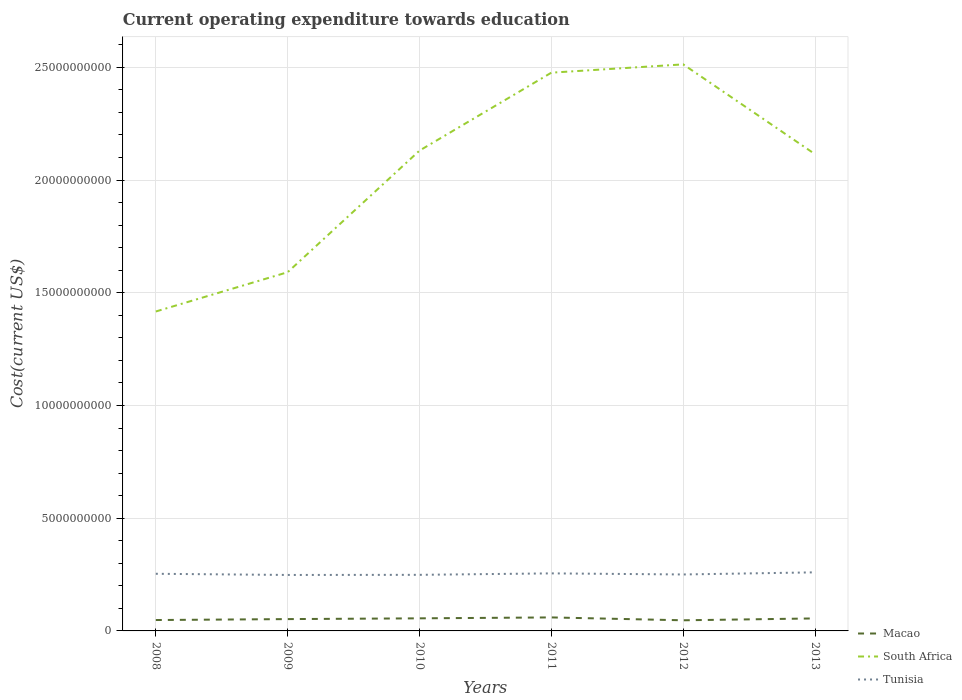How many different coloured lines are there?
Offer a terse response. 3. Does the line corresponding to Macao intersect with the line corresponding to Tunisia?
Make the answer very short. No. Is the number of lines equal to the number of legend labels?
Offer a terse response. Yes. Across all years, what is the maximum expenditure towards education in Tunisia?
Provide a short and direct response. 2.48e+09. What is the total expenditure towards education in Macao in the graph?
Provide a succinct answer. 4.42e+07. What is the difference between the highest and the second highest expenditure towards education in Macao?
Provide a short and direct response. 1.28e+08. Is the expenditure towards education in Tunisia strictly greater than the expenditure towards education in South Africa over the years?
Your response must be concise. Yes. What is the difference between two consecutive major ticks on the Y-axis?
Your answer should be very brief. 5.00e+09. Does the graph contain any zero values?
Ensure brevity in your answer.  No. Does the graph contain grids?
Keep it short and to the point. Yes. How many legend labels are there?
Ensure brevity in your answer.  3. How are the legend labels stacked?
Provide a succinct answer. Vertical. What is the title of the graph?
Your answer should be compact. Current operating expenditure towards education. Does "India" appear as one of the legend labels in the graph?
Your response must be concise. No. What is the label or title of the Y-axis?
Provide a succinct answer. Cost(current US$). What is the Cost(current US$) of Macao in 2008?
Your answer should be very brief. 4.83e+08. What is the Cost(current US$) in South Africa in 2008?
Your response must be concise. 1.42e+1. What is the Cost(current US$) in Tunisia in 2008?
Offer a very short reply. 2.53e+09. What is the Cost(current US$) in Macao in 2009?
Give a very brief answer. 5.25e+08. What is the Cost(current US$) of South Africa in 2009?
Keep it short and to the point. 1.59e+1. What is the Cost(current US$) in Tunisia in 2009?
Ensure brevity in your answer.  2.48e+09. What is the Cost(current US$) of Macao in 2010?
Ensure brevity in your answer.  5.58e+08. What is the Cost(current US$) of South Africa in 2010?
Give a very brief answer. 2.13e+1. What is the Cost(current US$) in Tunisia in 2010?
Offer a terse response. 2.49e+09. What is the Cost(current US$) of Macao in 2011?
Offer a very short reply. 5.99e+08. What is the Cost(current US$) in South Africa in 2011?
Ensure brevity in your answer.  2.48e+1. What is the Cost(current US$) of Tunisia in 2011?
Your response must be concise. 2.55e+09. What is the Cost(current US$) of Macao in 2012?
Provide a succinct answer. 4.71e+08. What is the Cost(current US$) in South Africa in 2012?
Provide a short and direct response. 2.51e+1. What is the Cost(current US$) of Tunisia in 2012?
Your response must be concise. 2.50e+09. What is the Cost(current US$) in Macao in 2013?
Provide a succinct answer. 5.55e+08. What is the Cost(current US$) in South Africa in 2013?
Offer a terse response. 2.11e+1. What is the Cost(current US$) of Tunisia in 2013?
Keep it short and to the point. 2.60e+09. Across all years, what is the maximum Cost(current US$) of Macao?
Give a very brief answer. 5.99e+08. Across all years, what is the maximum Cost(current US$) of South Africa?
Your answer should be very brief. 2.51e+1. Across all years, what is the maximum Cost(current US$) of Tunisia?
Offer a very short reply. 2.60e+09. Across all years, what is the minimum Cost(current US$) in Macao?
Your response must be concise. 4.71e+08. Across all years, what is the minimum Cost(current US$) of South Africa?
Keep it short and to the point. 1.42e+1. Across all years, what is the minimum Cost(current US$) in Tunisia?
Offer a terse response. 2.48e+09. What is the total Cost(current US$) in Macao in the graph?
Keep it short and to the point. 3.19e+09. What is the total Cost(current US$) in South Africa in the graph?
Keep it short and to the point. 1.22e+11. What is the total Cost(current US$) of Tunisia in the graph?
Keep it short and to the point. 1.52e+1. What is the difference between the Cost(current US$) in Macao in 2008 and that in 2009?
Ensure brevity in your answer.  -4.17e+07. What is the difference between the Cost(current US$) of South Africa in 2008 and that in 2009?
Your response must be concise. -1.74e+09. What is the difference between the Cost(current US$) of Tunisia in 2008 and that in 2009?
Provide a short and direct response. 5.23e+07. What is the difference between the Cost(current US$) in Macao in 2008 and that in 2010?
Your answer should be very brief. -7.51e+07. What is the difference between the Cost(current US$) of South Africa in 2008 and that in 2010?
Provide a succinct answer. -7.14e+09. What is the difference between the Cost(current US$) of Tunisia in 2008 and that in 2010?
Offer a terse response. 4.66e+07. What is the difference between the Cost(current US$) of Macao in 2008 and that in 2011?
Your answer should be compact. -1.16e+08. What is the difference between the Cost(current US$) in South Africa in 2008 and that in 2011?
Make the answer very short. -1.06e+1. What is the difference between the Cost(current US$) of Tunisia in 2008 and that in 2011?
Offer a very short reply. -1.80e+07. What is the difference between the Cost(current US$) of Macao in 2008 and that in 2012?
Your response must be concise. 1.18e+07. What is the difference between the Cost(current US$) in South Africa in 2008 and that in 2012?
Offer a very short reply. -1.10e+1. What is the difference between the Cost(current US$) of Tunisia in 2008 and that in 2012?
Give a very brief answer. 3.06e+07. What is the difference between the Cost(current US$) in Macao in 2008 and that in 2013?
Give a very brief answer. -7.16e+07. What is the difference between the Cost(current US$) of South Africa in 2008 and that in 2013?
Your response must be concise. -6.98e+09. What is the difference between the Cost(current US$) in Tunisia in 2008 and that in 2013?
Your answer should be compact. -6.39e+07. What is the difference between the Cost(current US$) of Macao in 2009 and that in 2010?
Offer a terse response. -3.34e+07. What is the difference between the Cost(current US$) in South Africa in 2009 and that in 2010?
Offer a terse response. -5.39e+09. What is the difference between the Cost(current US$) in Tunisia in 2009 and that in 2010?
Offer a very short reply. -5.75e+06. What is the difference between the Cost(current US$) of Macao in 2009 and that in 2011?
Give a very brief answer. -7.42e+07. What is the difference between the Cost(current US$) of South Africa in 2009 and that in 2011?
Ensure brevity in your answer.  -8.85e+09. What is the difference between the Cost(current US$) of Tunisia in 2009 and that in 2011?
Provide a short and direct response. -7.03e+07. What is the difference between the Cost(current US$) of Macao in 2009 and that in 2012?
Your answer should be very brief. 5.34e+07. What is the difference between the Cost(current US$) of South Africa in 2009 and that in 2012?
Your answer should be compact. -9.22e+09. What is the difference between the Cost(current US$) of Tunisia in 2009 and that in 2012?
Give a very brief answer. -2.17e+07. What is the difference between the Cost(current US$) of Macao in 2009 and that in 2013?
Offer a terse response. -2.99e+07. What is the difference between the Cost(current US$) of South Africa in 2009 and that in 2013?
Offer a very short reply. -5.23e+09. What is the difference between the Cost(current US$) of Tunisia in 2009 and that in 2013?
Provide a succinct answer. -1.16e+08. What is the difference between the Cost(current US$) in Macao in 2010 and that in 2011?
Offer a very short reply. -4.08e+07. What is the difference between the Cost(current US$) in South Africa in 2010 and that in 2011?
Your response must be concise. -3.46e+09. What is the difference between the Cost(current US$) in Tunisia in 2010 and that in 2011?
Your response must be concise. -6.46e+07. What is the difference between the Cost(current US$) of Macao in 2010 and that in 2012?
Provide a succinct answer. 8.69e+07. What is the difference between the Cost(current US$) of South Africa in 2010 and that in 2012?
Provide a short and direct response. -3.82e+09. What is the difference between the Cost(current US$) in Tunisia in 2010 and that in 2012?
Your answer should be compact. -1.60e+07. What is the difference between the Cost(current US$) in Macao in 2010 and that in 2013?
Your response must be concise. 3.47e+06. What is the difference between the Cost(current US$) in South Africa in 2010 and that in 2013?
Offer a very short reply. 1.60e+08. What is the difference between the Cost(current US$) in Tunisia in 2010 and that in 2013?
Offer a very short reply. -1.10e+08. What is the difference between the Cost(current US$) of Macao in 2011 and that in 2012?
Provide a short and direct response. 1.28e+08. What is the difference between the Cost(current US$) in South Africa in 2011 and that in 2012?
Give a very brief answer. -3.68e+08. What is the difference between the Cost(current US$) in Tunisia in 2011 and that in 2012?
Your answer should be very brief. 4.86e+07. What is the difference between the Cost(current US$) of Macao in 2011 and that in 2013?
Offer a terse response. 4.42e+07. What is the difference between the Cost(current US$) of South Africa in 2011 and that in 2013?
Give a very brief answer. 3.62e+09. What is the difference between the Cost(current US$) in Tunisia in 2011 and that in 2013?
Offer a very short reply. -4.59e+07. What is the difference between the Cost(current US$) in Macao in 2012 and that in 2013?
Give a very brief answer. -8.34e+07. What is the difference between the Cost(current US$) of South Africa in 2012 and that in 2013?
Your answer should be very brief. 3.98e+09. What is the difference between the Cost(current US$) in Tunisia in 2012 and that in 2013?
Your answer should be compact. -9.45e+07. What is the difference between the Cost(current US$) of Macao in 2008 and the Cost(current US$) of South Africa in 2009?
Make the answer very short. -1.54e+1. What is the difference between the Cost(current US$) of Macao in 2008 and the Cost(current US$) of Tunisia in 2009?
Make the answer very short. -2.00e+09. What is the difference between the Cost(current US$) of South Africa in 2008 and the Cost(current US$) of Tunisia in 2009?
Provide a short and direct response. 1.17e+1. What is the difference between the Cost(current US$) of Macao in 2008 and the Cost(current US$) of South Africa in 2010?
Ensure brevity in your answer.  -2.08e+1. What is the difference between the Cost(current US$) in Macao in 2008 and the Cost(current US$) in Tunisia in 2010?
Make the answer very short. -2.00e+09. What is the difference between the Cost(current US$) in South Africa in 2008 and the Cost(current US$) in Tunisia in 2010?
Your answer should be very brief. 1.17e+1. What is the difference between the Cost(current US$) of Macao in 2008 and the Cost(current US$) of South Africa in 2011?
Make the answer very short. -2.43e+1. What is the difference between the Cost(current US$) in Macao in 2008 and the Cost(current US$) in Tunisia in 2011?
Make the answer very short. -2.07e+09. What is the difference between the Cost(current US$) of South Africa in 2008 and the Cost(current US$) of Tunisia in 2011?
Your answer should be very brief. 1.16e+1. What is the difference between the Cost(current US$) in Macao in 2008 and the Cost(current US$) in South Africa in 2012?
Provide a short and direct response. -2.46e+1. What is the difference between the Cost(current US$) in Macao in 2008 and the Cost(current US$) in Tunisia in 2012?
Your answer should be very brief. -2.02e+09. What is the difference between the Cost(current US$) of South Africa in 2008 and the Cost(current US$) of Tunisia in 2012?
Keep it short and to the point. 1.17e+1. What is the difference between the Cost(current US$) of Macao in 2008 and the Cost(current US$) of South Africa in 2013?
Your answer should be compact. -2.07e+1. What is the difference between the Cost(current US$) of Macao in 2008 and the Cost(current US$) of Tunisia in 2013?
Your answer should be compact. -2.12e+09. What is the difference between the Cost(current US$) of South Africa in 2008 and the Cost(current US$) of Tunisia in 2013?
Provide a succinct answer. 1.16e+1. What is the difference between the Cost(current US$) of Macao in 2009 and the Cost(current US$) of South Africa in 2010?
Your response must be concise. -2.08e+1. What is the difference between the Cost(current US$) of Macao in 2009 and the Cost(current US$) of Tunisia in 2010?
Offer a very short reply. -1.96e+09. What is the difference between the Cost(current US$) of South Africa in 2009 and the Cost(current US$) of Tunisia in 2010?
Offer a terse response. 1.34e+1. What is the difference between the Cost(current US$) of Macao in 2009 and the Cost(current US$) of South Africa in 2011?
Your answer should be very brief. -2.42e+1. What is the difference between the Cost(current US$) in Macao in 2009 and the Cost(current US$) in Tunisia in 2011?
Your answer should be compact. -2.03e+09. What is the difference between the Cost(current US$) in South Africa in 2009 and the Cost(current US$) in Tunisia in 2011?
Offer a very short reply. 1.34e+1. What is the difference between the Cost(current US$) of Macao in 2009 and the Cost(current US$) of South Africa in 2012?
Provide a succinct answer. -2.46e+1. What is the difference between the Cost(current US$) of Macao in 2009 and the Cost(current US$) of Tunisia in 2012?
Give a very brief answer. -1.98e+09. What is the difference between the Cost(current US$) of South Africa in 2009 and the Cost(current US$) of Tunisia in 2012?
Your answer should be very brief. 1.34e+1. What is the difference between the Cost(current US$) in Macao in 2009 and the Cost(current US$) in South Africa in 2013?
Provide a succinct answer. -2.06e+1. What is the difference between the Cost(current US$) of Macao in 2009 and the Cost(current US$) of Tunisia in 2013?
Provide a short and direct response. -2.07e+09. What is the difference between the Cost(current US$) of South Africa in 2009 and the Cost(current US$) of Tunisia in 2013?
Your response must be concise. 1.33e+1. What is the difference between the Cost(current US$) in Macao in 2010 and the Cost(current US$) in South Africa in 2011?
Offer a very short reply. -2.42e+1. What is the difference between the Cost(current US$) in Macao in 2010 and the Cost(current US$) in Tunisia in 2011?
Keep it short and to the point. -1.99e+09. What is the difference between the Cost(current US$) of South Africa in 2010 and the Cost(current US$) of Tunisia in 2011?
Give a very brief answer. 1.88e+1. What is the difference between the Cost(current US$) of Macao in 2010 and the Cost(current US$) of South Africa in 2012?
Your answer should be very brief. -2.46e+1. What is the difference between the Cost(current US$) of Macao in 2010 and the Cost(current US$) of Tunisia in 2012?
Offer a very short reply. -1.95e+09. What is the difference between the Cost(current US$) in South Africa in 2010 and the Cost(current US$) in Tunisia in 2012?
Provide a succinct answer. 1.88e+1. What is the difference between the Cost(current US$) of Macao in 2010 and the Cost(current US$) of South Africa in 2013?
Offer a terse response. -2.06e+1. What is the difference between the Cost(current US$) in Macao in 2010 and the Cost(current US$) in Tunisia in 2013?
Your answer should be compact. -2.04e+09. What is the difference between the Cost(current US$) of South Africa in 2010 and the Cost(current US$) of Tunisia in 2013?
Ensure brevity in your answer.  1.87e+1. What is the difference between the Cost(current US$) of Macao in 2011 and the Cost(current US$) of South Africa in 2012?
Your response must be concise. -2.45e+1. What is the difference between the Cost(current US$) in Macao in 2011 and the Cost(current US$) in Tunisia in 2012?
Your answer should be very brief. -1.91e+09. What is the difference between the Cost(current US$) in South Africa in 2011 and the Cost(current US$) in Tunisia in 2012?
Give a very brief answer. 2.23e+1. What is the difference between the Cost(current US$) of Macao in 2011 and the Cost(current US$) of South Africa in 2013?
Keep it short and to the point. -2.05e+1. What is the difference between the Cost(current US$) of Macao in 2011 and the Cost(current US$) of Tunisia in 2013?
Make the answer very short. -2.00e+09. What is the difference between the Cost(current US$) of South Africa in 2011 and the Cost(current US$) of Tunisia in 2013?
Make the answer very short. 2.22e+1. What is the difference between the Cost(current US$) of Macao in 2012 and the Cost(current US$) of South Africa in 2013?
Ensure brevity in your answer.  -2.07e+1. What is the difference between the Cost(current US$) in Macao in 2012 and the Cost(current US$) in Tunisia in 2013?
Provide a succinct answer. -2.13e+09. What is the difference between the Cost(current US$) in South Africa in 2012 and the Cost(current US$) in Tunisia in 2013?
Make the answer very short. 2.25e+1. What is the average Cost(current US$) in Macao per year?
Your response must be concise. 5.32e+08. What is the average Cost(current US$) of South Africa per year?
Ensure brevity in your answer.  2.04e+1. What is the average Cost(current US$) in Tunisia per year?
Provide a short and direct response. 2.53e+09. In the year 2008, what is the difference between the Cost(current US$) in Macao and Cost(current US$) in South Africa?
Offer a terse response. -1.37e+1. In the year 2008, what is the difference between the Cost(current US$) of Macao and Cost(current US$) of Tunisia?
Your response must be concise. -2.05e+09. In the year 2008, what is the difference between the Cost(current US$) of South Africa and Cost(current US$) of Tunisia?
Give a very brief answer. 1.16e+1. In the year 2009, what is the difference between the Cost(current US$) of Macao and Cost(current US$) of South Africa?
Your answer should be very brief. -1.54e+1. In the year 2009, what is the difference between the Cost(current US$) in Macao and Cost(current US$) in Tunisia?
Provide a succinct answer. -1.96e+09. In the year 2009, what is the difference between the Cost(current US$) of South Africa and Cost(current US$) of Tunisia?
Your answer should be compact. 1.34e+1. In the year 2010, what is the difference between the Cost(current US$) of Macao and Cost(current US$) of South Africa?
Ensure brevity in your answer.  -2.07e+1. In the year 2010, what is the difference between the Cost(current US$) of Macao and Cost(current US$) of Tunisia?
Your response must be concise. -1.93e+09. In the year 2010, what is the difference between the Cost(current US$) in South Africa and Cost(current US$) in Tunisia?
Ensure brevity in your answer.  1.88e+1. In the year 2011, what is the difference between the Cost(current US$) in Macao and Cost(current US$) in South Africa?
Ensure brevity in your answer.  -2.42e+1. In the year 2011, what is the difference between the Cost(current US$) of Macao and Cost(current US$) of Tunisia?
Ensure brevity in your answer.  -1.95e+09. In the year 2011, what is the difference between the Cost(current US$) in South Africa and Cost(current US$) in Tunisia?
Your response must be concise. 2.22e+1. In the year 2012, what is the difference between the Cost(current US$) in Macao and Cost(current US$) in South Africa?
Provide a succinct answer. -2.47e+1. In the year 2012, what is the difference between the Cost(current US$) of Macao and Cost(current US$) of Tunisia?
Provide a short and direct response. -2.03e+09. In the year 2012, what is the difference between the Cost(current US$) in South Africa and Cost(current US$) in Tunisia?
Your response must be concise. 2.26e+1. In the year 2013, what is the difference between the Cost(current US$) in Macao and Cost(current US$) in South Africa?
Ensure brevity in your answer.  -2.06e+1. In the year 2013, what is the difference between the Cost(current US$) of Macao and Cost(current US$) of Tunisia?
Your answer should be very brief. -2.04e+09. In the year 2013, what is the difference between the Cost(current US$) of South Africa and Cost(current US$) of Tunisia?
Provide a short and direct response. 1.85e+1. What is the ratio of the Cost(current US$) in Macao in 2008 to that in 2009?
Give a very brief answer. 0.92. What is the ratio of the Cost(current US$) in South Africa in 2008 to that in 2009?
Keep it short and to the point. 0.89. What is the ratio of the Cost(current US$) of Tunisia in 2008 to that in 2009?
Give a very brief answer. 1.02. What is the ratio of the Cost(current US$) of Macao in 2008 to that in 2010?
Provide a succinct answer. 0.87. What is the ratio of the Cost(current US$) of South Africa in 2008 to that in 2010?
Your response must be concise. 0.67. What is the ratio of the Cost(current US$) of Tunisia in 2008 to that in 2010?
Offer a terse response. 1.02. What is the ratio of the Cost(current US$) of Macao in 2008 to that in 2011?
Ensure brevity in your answer.  0.81. What is the ratio of the Cost(current US$) of South Africa in 2008 to that in 2011?
Give a very brief answer. 0.57. What is the ratio of the Cost(current US$) in Tunisia in 2008 to that in 2011?
Provide a short and direct response. 0.99. What is the ratio of the Cost(current US$) in Macao in 2008 to that in 2012?
Provide a succinct answer. 1.02. What is the ratio of the Cost(current US$) in South Africa in 2008 to that in 2012?
Keep it short and to the point. 0.56. What is the ratio of the Cost(current US$) in Tunisia in 2008 to that in 2012?
Provide a succinct answer. 1.01. What is the ratio of the Cost(current US$) of Macao in 2008 to that in 2013?
Make the answer very short. 0.87. What is the ratio of the Cost(current US$) of South Africa in 2008 to that in 2013?
Ensure brevity in your answer.  0.67. What is the ratio of the Cost(current US$) of Tunisia in 2008 to that in 2013?
Offer a terse response. 0.98. What is the ratio of the Cost(current US$) in Macao in 2009 to that in 2010?
Make the answer very short. 0.94. What is the ratio of the Cost(current US$) of South Africa in 2009 to that in 2010?
Offer a very short reply. 0.75. What is the ratio of the Cost(current US$) of Tunisia in 2009 to that in 2010?
Your answer should be compact. 1. What is the ratio of the Cost(current US$) of Macao in 2009 to that in 2011?
Keep it short and to the point. 0.88. What is the ratio of the Cost(current US$) of South Africa in 2009 to that in 2011?
Ensure brevity in your answer.  0.64. What is the ratio of the Cost(current US$) of Tunisia in 2009 to that in 2011?
Offer a terse response. 0.97. What is the ratio of the Cost(current US$) of Macao in 2009 to that in 2012?
Make the answer very short. 1.11. What is the ratio of the Cost(current US$) of South Africa in 2009 to that in 2012?
Offer a terse response. 0.63. What is the ratio of the Cost(current US$) in Macao in 2009 to that in 2013?
Give a very brief answer. 0.95. What is the ratio of the Cost(current US$) in South Africa in 2009 to that in 2013?
Your response must be concise. 0.75. What is the ratio of the Cost(current US$) of Tunisia in 2009 to that in 2013?
Your response must be concise. 0.96. What is the ratio of the Cost(current US$) in Macao in 2010 to that in 2011?
Keep it short and to the point. 0.93. What is the ratio of the Cost(current US$) of South Africa in 2010 to that in 2011?
Make the answer very short. 0.86. What is the ratio of the Cost(current US$) in Tunisia in 2010 to that in 2011?
Make the answer very short. 0.97. What is the ratio of the Cost(current US$) in Macao in 2010 to that in 2012?
Keep it short and to the point. 1.18. What is the ratio of the Cost(current US$) of South Africa in 2010 to that in 2012?
Give a very brief answer. 0.85. What is the ratio of the Cost(current US$) of Tunisia in 2010 to that in 2012?
Your answer should be very brief. 0.99. What is the ratio of the Cost(current US$) of South Africa in 2010 to that in 2013?
Your answer should be very brief. 1.01. What is the ratio of the Cost(current US$) of Tunisia in 2010 to that in 2013?
Your answer should be very brief. 0.96. What is the ratio of the Cost(current US$) in Macao in 2011 to that in 2012?
Your response must be concise. 1.27. What is the ratio of the Cost(current US$) in South Africa in 2011 to that in 2012?
Provide a succinct answer. 0.99. What is the ratio of the Cost(current US$) in Tunisia in 2011 to that in 2012?
Your answer should be compact. 1.02. What is the ratio of the Cost(current US$) of Macao in 2011 to that in 2013?
Provide a succinct answer. 1.08. What is the ratio of the Cost(current US$) in South Africa in 2011 to that in 2013?
Keep it short and to the point. 1.17. What is the ratio of the Cost(current US$) of Tunisia in 2011 to that in 2013?
Your answer should be very brief. 0.98. What is the ratio of the Cost(current US$) of Macao in 2012 to that in 2013?
Keep it short and to the point. 0.85. What is the ratio of the Cost(current US$) of South Africa in 2012 to that in 2013?
Your response must be concise. 1.19. What is the ratio of the Cost(current US$) of Tunisia in 2012 to that in 2013?
Provide a short and direct response. 0.96. What is the difference between the highest and the second highest Cost(current US$) in Macao?
Keep it short and to the point. 4.08e+07. What is the difference between the highest and the second highest Cost(current US$) of South Africa?
Keep it short and to the point. 3.68e+08. What is the difference between the highest and the second highest Cost(current US$) in Tunisia?
Make the answer very short. 4.59e+07. What is the difference between the highest and the lowest Cost(current US$) in Macao?
Your answer should be very brief. 1.28e+08. What is the difference between the highest and the lowest Cost(current US$) of South Africa?
Keep it short and to the point. 1.10e+1. What is the difference between the highest and the lowest Cost(current US$) in Tunisia?
Provide a succinct answer. 1.16e+08. 